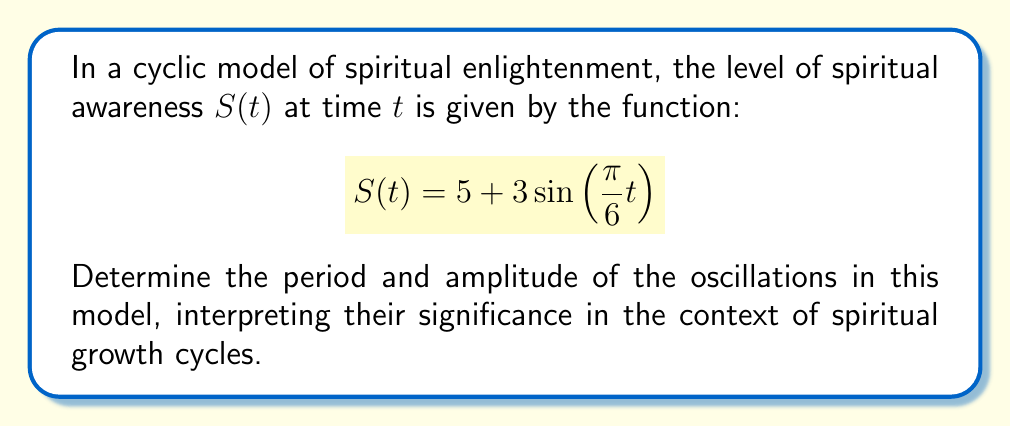Teach me how to tackle this problem. To determine the period and amplitude of the oscillations, we'll analyze the given function:

$$S(t) = 5 + 3\sin(\frac{\pi}{6}t)$$

1. Amplitude:
   The amplitude is the maximum displacement from the midline of the oscillation. In the general form $A\sin(Bt)$, $A$ represents the amplitude. Here, the amplitude is 3.

2. Period:
   The period is the time taken for one complete cycle of the oscillation. For a sine function of the form $\sin(Bt)$, the period is given by $\frac{2\pi}{|B|}$.

   In this case, $B = \frac{\pi}{6}$

   Period = $\frac{2\pi}{|\frac{\pi}{6}|} = \frac{2\pi}{\frac{\pi}{6}} = 2 \cdot 6 = 12$

Interpretation:
- The amplitude of 3 suggests that the spiritual awareness fluctuates 3 units above and below the mean level of 5.
- The period of 12 indicates that a complete cycle of spiritual growth and decline takes 12 time units (e.g., months if t is measured in months).

This cyclic model represents the ebb and flow of spiritual awareness, with regular periods of heightened enlightenment followed by times of lesser awareness, reflecting the natural rhythms of spiritual growth as often described in various spiritual teachings.
Answer: Period: 12, Amplitude: 3 